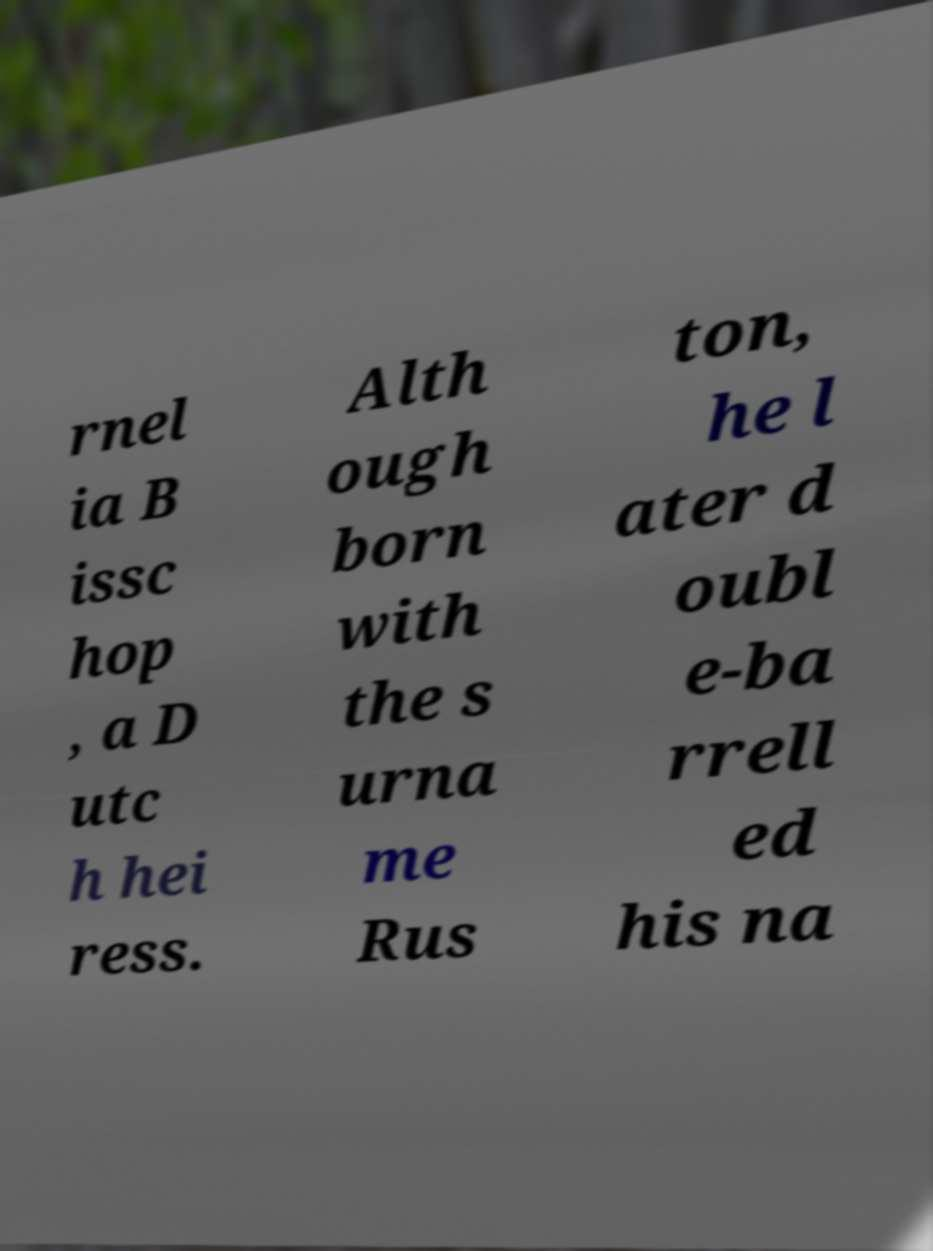What messages or text are displayed in this image? I need them in a readable, typed format. rnel ia B issc hop , a D utc h hei ress. Alth ough born with the s urna me Rus ton, he l ater d oubl e-ba rrell ed his na 